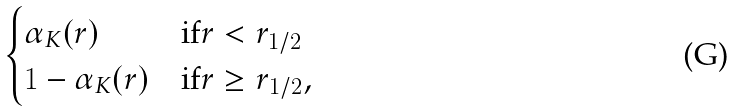<formula> <loc_0><loc_0><loc_500><loc_500>\begin{cases} \alpha _ { K } ( r ) & \text {if} r < r _ { 1 / 2 } \\ 1 - \alpha _ { K } ( r ) & \text {if} r \geq r _ { 1 / 2 } , \end{cases}</formula> 